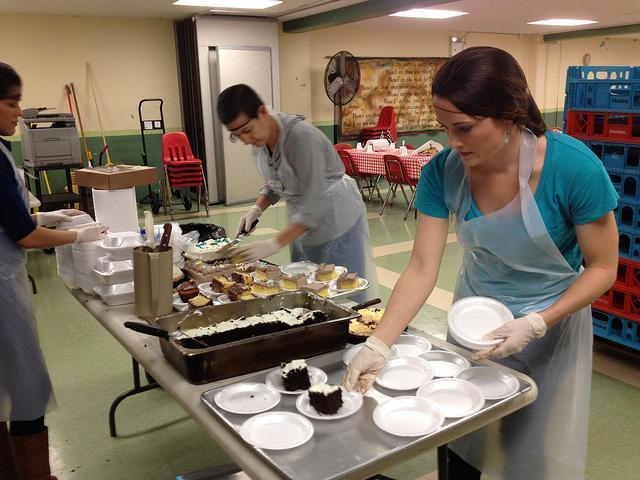How many people are here?
Give a very brief answer. 3. How many dining tables are there?
Give a very brief answer. 3. How many people can be seen?
Give a very brief answer. 3. How many bananas do you see?
Give a very brief answer. 0. 